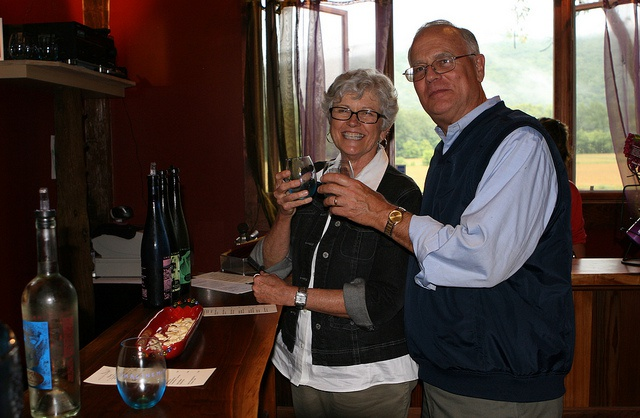Describe the objects in this image and their specific colors. I can see people in maroon, black, darkgray, and brown tones, bottle in maroon, black, and gray tones, cup in maroon, black, darkgray, and gray tones, bottle in maroon, black, gray, and brown tones, and wine glass in maroon, black, darkgray, and tan tones in this image. 